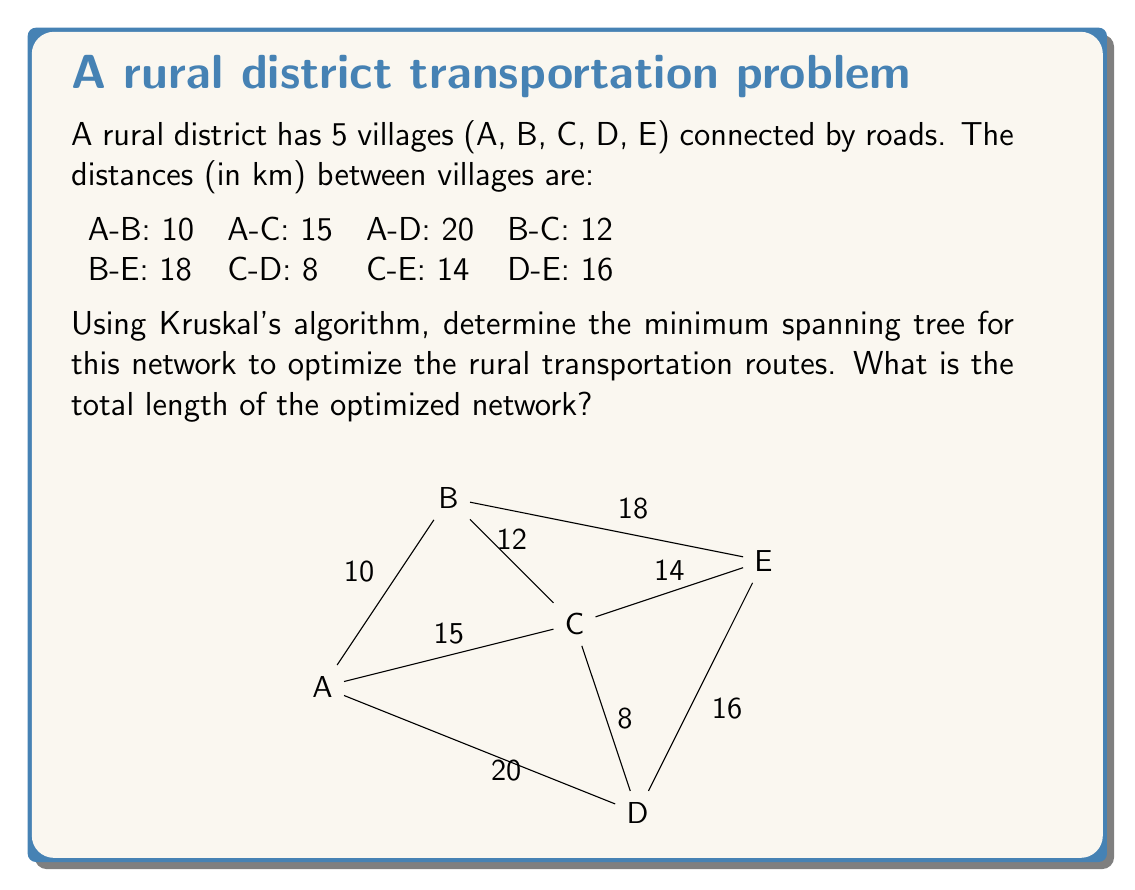Could you help me with this problem? To solve this problem using Kruskal's algorithm, we follow these steps:

1. Sort all edges by weight (distance) in ascending order:
   C-D: 8, A-B: 10, B-C: 12, C-E: 14, A-C: 15, D-E: 16, B-E: 18, A-D: 20

2. Start with an empty graph and add edges one by one, avoiding cycles:

   a) Add C-D (8 km)
   b) Add A-B (10 km)
   c) Add B-C (12 km)
   d) Skip C-E (would create a cycle)
   e) Skip A-C (would create a cycle)
   f) Add D-E (16 km)

3. The algorithm stops here as we have added 4 edges, which is sufficient for a minimum spanning tree with 5 vertices (n-1 edges, where n is the number of vertices).

The resulting minimum spanning tree consists of the edges:
C-D, A-B, B-C, and D-E

To calculate the total length of the optimized network, we sum the distances of these edges:

$$ \text{Total length} = 8 + 10 + 12 + 16 = 46 \text{ km} $$

This minimum spanning tree represents the most efficient way to connect all villages while minimizing the total road length, which is crucial for optimizing rural transportation networks and reducing infrastructure costs.
Answer: The total length of the optimized rural transportation network is 46 km. 